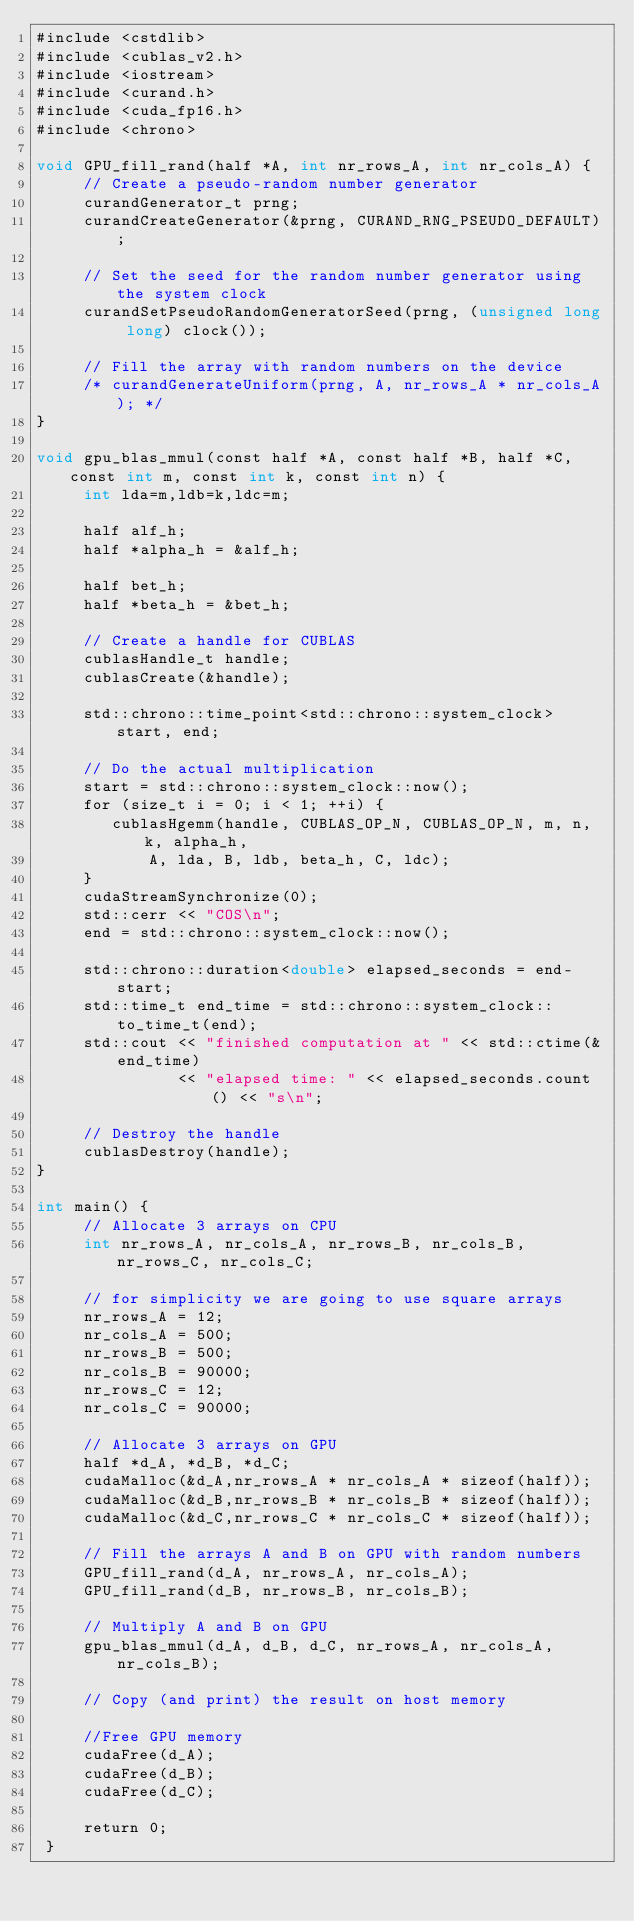<code> <loc_0><loc_0><loc_500><loc_500><_Cuda_>#include <cstdlib>
#include <cublas_v2.h>
#include <iostream>
#include <curand.h>
#include <cuda_fp16.h>
#include <chrono>

void GPU_fill_rand(half *A, int nr_rows_A, int nr_cols_A) {
     // Create a pseudo-random number generator
     curandGenerator_t prng;
     curandCreateGenerator(&prng, CURAND_RNG_PSEUDO_DEFAULT);

     // Set the seed for the random number generator using the system clock
     curandSetPseudoRandomGeneratorSeed(prng, (unsigned long long) clock());

     // Fill the array with random numbers on the device
     /* curandGenerateUniform(prng, A, nr_rows_A * nr_cols_A); */
}

void gpu_blas_mmul(const half *A, const half *B, half *C, const int m, const int k, const int n) {
     int lda=m,ldb=k,ldc=m;

     half alf_h;
     half *alpha_h = &alf_h;

     half bet_h;
     half *beta_h = &bet_h;

     // Create a handle for CUBLAS
     cublasHandle_t handle;
     cublasCreate(&handle);

     std::chrono::time_point<std::chrono::system_clock> start, end;

     // Do the actual multiplication
     start = std::chrono::system_clock::now();
     for (size_t i = 0; i < 1; ++i) {
        cublasHgemm(handle, CUBLAS_OP_N, CUBLAS_OP_N, m, n, k, alpha_h,
            A, lda, B, ldb, beta_h, C, ldc);
     }
     cudaStreamSynchronize(0);
     std::cerr << "COS\n";
     end = std::chrono::system_clock::now();

     std::chrono::duration<double> elapsed_seconds = end-start;
     std::time_t end_time = std::chrono::system_clock::to_time_t(end);
     std::cout << "finished computation at " << std::ctime(&end_time)
               << "elapsed time: " << elapsed_seconds.count() << "s\n";

     // Destroy the handle
     cublasDestroy(handle);
}

int main() {
     // Allocate 3 arrays on CPU
     int nr_rows_A, nr_cols_A, nr_rows_B, nr_cols_B, nr_rows_C, nr_cols_C;

     // for simplicity we are going to use square arrays
     nr_rows_A = 12;
     nr_cols_A = 500;
     nr_rows_B = 500;
     nr_cols_B = 90000;
     nr_rows_C = 12;
     nr_cols_C = 90000;

     // Allocate 3 arrays on GPU
     half *d_A, *d_B, *d_C;
     cudaMalloc(&d_A,nr_rows_A * nr_cols_A * sizeof(half));
     cudaMalloc(&d_B,nr_rows_B * nr_cols_B * sizeof(half));
     cudaMalloc(&d_C,nr_rows_C * nr_cols_C * sizeof(half));

     // Fill the arrays A and B on GPU with random numbers
     GPU_fill_rand(d_A, nr_rows_A, nr_cols_A);
     GPU_fill_rand(d_B, nr_rows_B, nr_cols_B);

     // Multiply A and B on GPU
     gpu_blas_mmul(d_A, d_B, d_C, nr_rows_A, nr_cols_A, nr_cols_B);

     // Copy (and print) the result on host memory

     //Free GPU memory
     cudaFree(d_A);
     cudaFree(d_B);
     cudaFree(d_C);  

     return 0;
 }
</code> 